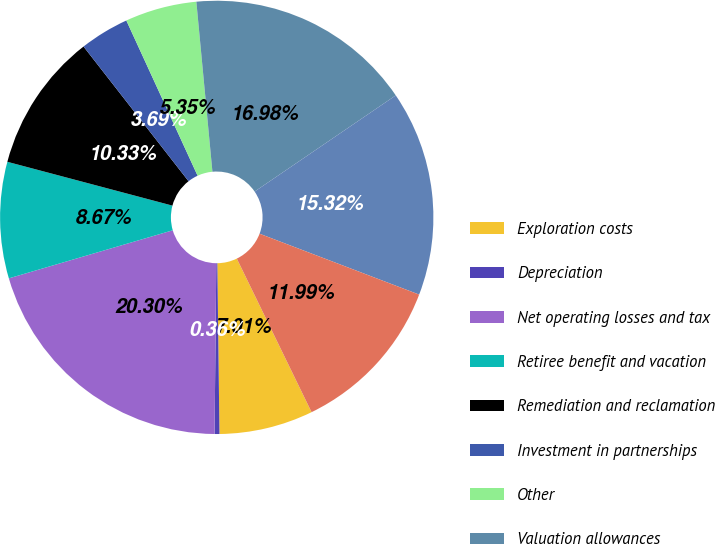Convert chart to OTSL. <chart><loc_0><loc_0><loc_500><loc_500><pie_chart><fcel>Exploration costs<fcel>Depreciation<fcel>Net operating losses and tax<fcel>Retiree benefit and vacation<fcel>Remediation and reclamation<fcel>Investment in partnerships<fcel>Other<fcel>Valuation allowances<fcel>Net undistributed earnings of<fcel>Unrealized gain on investments<nl><fcel>7.01%<fcel>0.36%<fcel>20.3%<fcel>8.67%<fcel>10.33%<fcel>3.69%<fcel>5.35%<fcel>16.98%<fcel>15.32%<fcel>11.99%<nl></chart> 